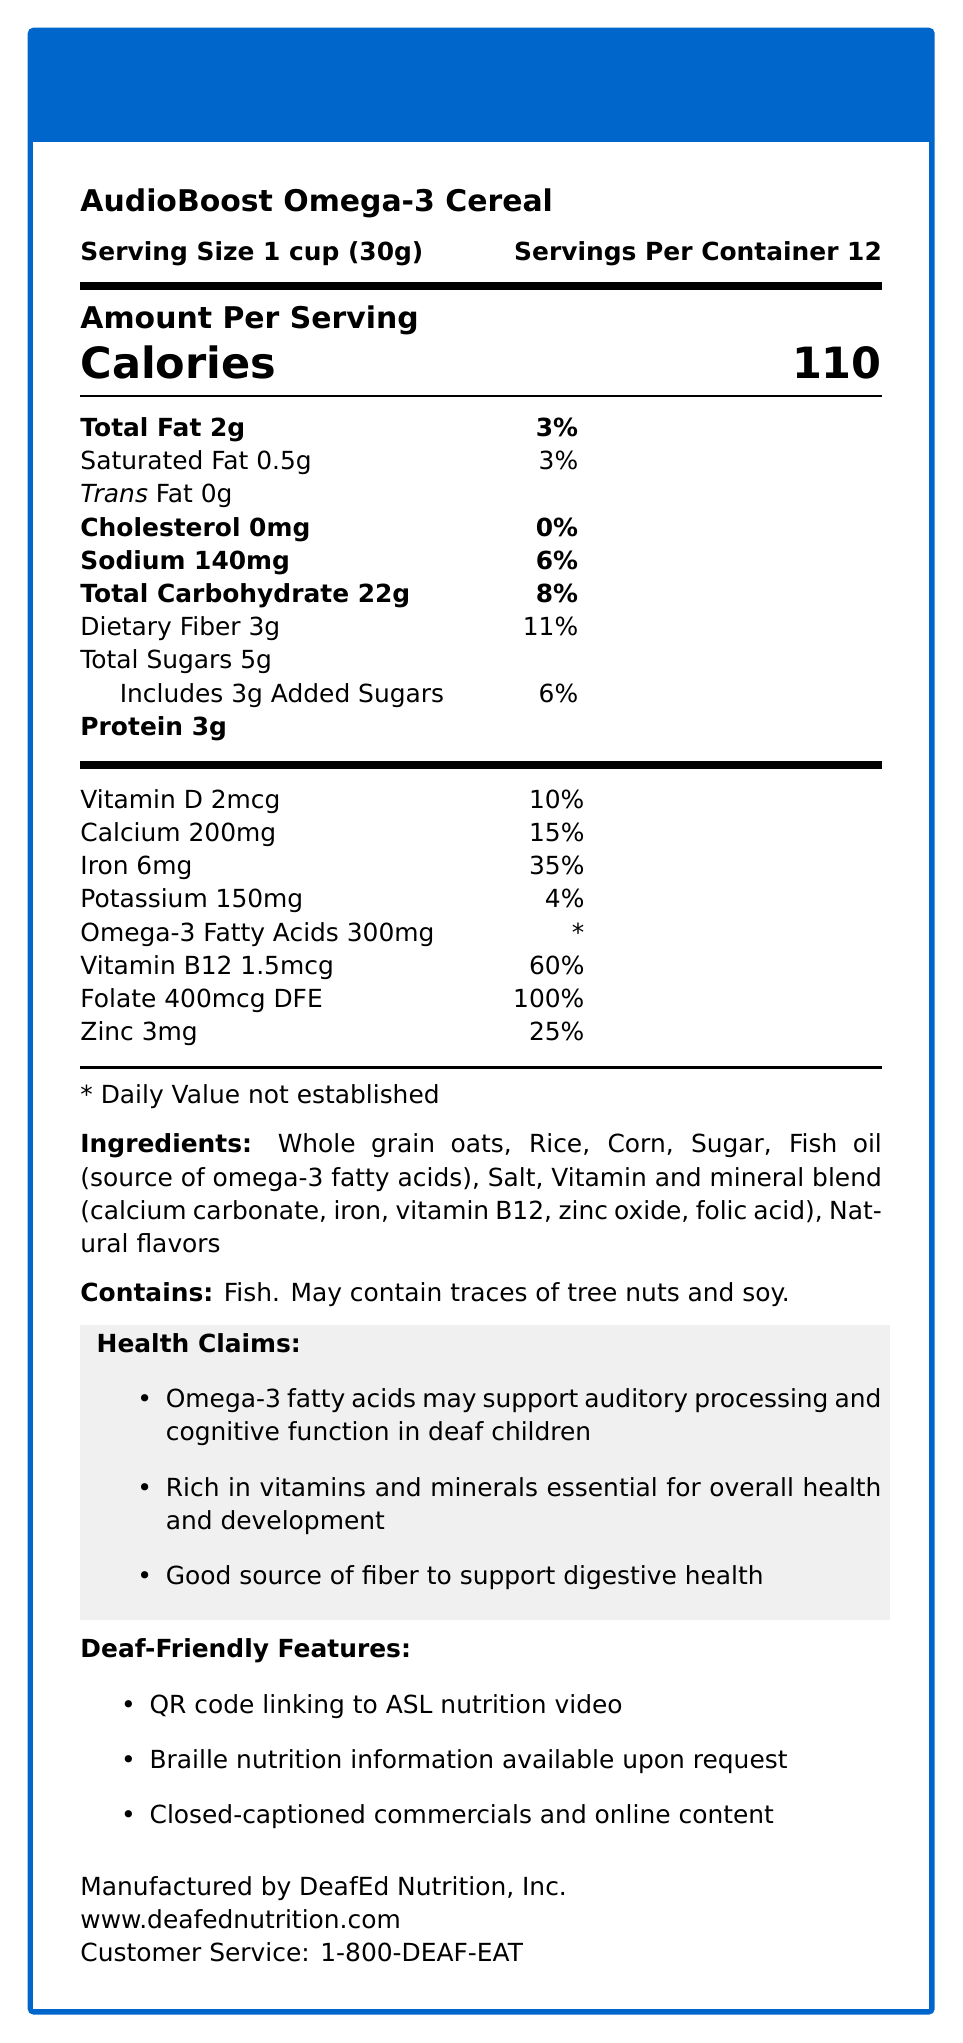what is the serving size? The serving size is explicitly mentioned at the beginning of the document as "Serving Size 1 cup (30g)."
Answer: 1 cup (30g) how many calories are in one serving? The calories per serving are clearly stated in the "Amount Per Serving" section as "Calories 110."
Answer: 110 what is the amount of dietary fiber per serving and its daily value percentage? The document shows dietary fiber amounts to 3g per serving with a daily value percentage of 11%.
Answer: 3g, 11% does the cereal contain any trans fat? The document explicitly lists trans fat as "0g," indicating that the cereal does not contain any trans fat.
Answer: No how many servings are in one container? The servings per container are specified near the top of the document as "Servings Per Container 12."
Answer: 12 what vitamins and minerals are prominently listed with their daily value percentages? A. Vitamin D, Calcium, Iron, Vitamin B12, Folate, Zinc B. Vitamin C, Magnesium, Vitamin E, Selenium C. Vitamin A, Phosphorus, Vitamin K, Copper The listed vitamins and minerals with their daily values include Vitamin D, Calcium, Iron, Vitamin B12, Folate, and Zinc.
Answer: A which of the following ingredients is an allergen in the cereal? I. Wheat II. Fish III. Peanuts IV. Soy The document states "Contains fish" and "May contain traces of tree nuts and soy," indicating that fish and soy are allergens in the cereal.
Answer: II, IV is the cereal a good source of Omega-3 fatty acids? The cereal contains 300mg of Omega-3 fatty acids per serving, which is significant.
Answer: Yes does this cereal contain any cholesterol? The document clearly lists cholesterol as "0mg," indicating there is no cholesterol in the cereal.
Answer: No summarize the main health benefits and features of AudioBoost Omega-3 Cereal The document emphasizes the nutritional benefits and unique features for deaf individuals, including omega-3 fatty acids for auditory support, essential vitamins and minerals for overall health, dietary fiber, and accessible information options for the deaf community.
Answer: The AudioBoost Omega-3 Cereal is fortified with 300mg of omega-3 fatty acids per serving, supporting auditory processing and cognitive function in deaf children. It is also rich in essential vitamins and minerals, including vitamin B12, folate, calcium, and iron, promoting overall health and development. The cereal contains dietary fiber for digestive health and features unique deaf-friendly options like a QR code to an ASL nutrition video, Braille nutrition information, and closed-captioned content. what is the source of omega-3 fatty acids in the ingredients list? The document specifically lists "Fish oil (source of omega-3 fatty acids)" in the ingredients section.
Answer: Fish oil which vitamin has the highest daily value percentage per serving? The document lists the daily value of folate as 100%, which is higher than any other vitamin or mineral shown.
Answer: Folate based on the document, can it be determined where the ingredients are sourced from? The document does not provide any information about the source or origin locations of the ingredients used in the cereal.
Answer: Cannot be determined 